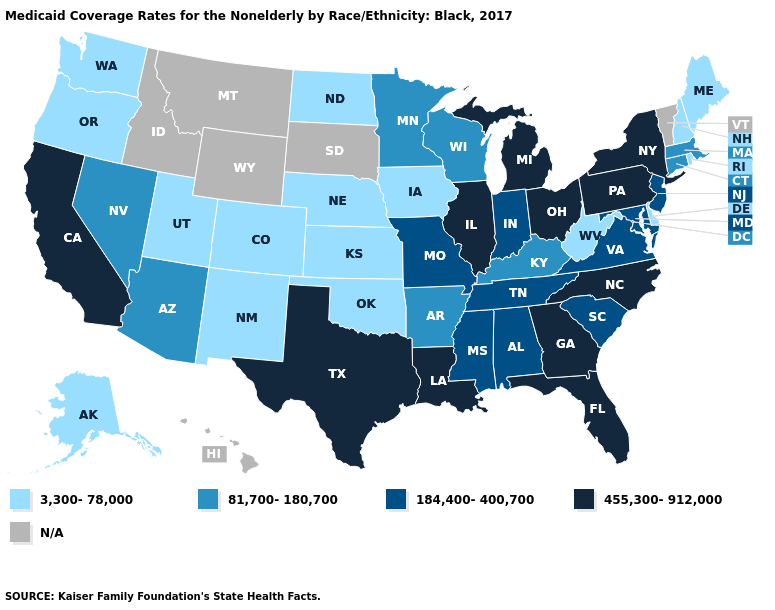What is the value of Virginia?
Be succinct. 184,400-400,700. Does New Jersey have the highest value in the Northeast?
Answer briefly. No. What is the highest value in the MidWest ?
Answer briefly. 455,300-912,000. Name the states that have a value in the range 3,300-78,000?
Write a very short answer. Alaska, Colorado, Delaware, Iowa, Kansas, Maine, Nebraska, New Hampshire, New Mexico, North Dakota, Oklahoma, Oregon, Rhode Island, Utah, Washington, West Virginia. What is the value of North Carolina?
Keep it brief. 455,300-912,000. What is the value of Louisiana?
Give a very brief answer. 455,300-912,000. What is the value of Vermont?
Give a very brief answer. N/A. What is the highest value in the South ?
Write a very short answer. 455,300-912,000. Does New York have the highest value in the Northeast?
Write a very short answer. Yes. Does the first symbol in the legend represent the smallest category?
Write a very short answer. Yes. Name the states that have a value in the range 184,400-400,700?
Write a very short answer. Alabama, Indiana, Maryland, Mississippi, Missouri, New Jersey, South Carolina, Tennessee, Virginia. What is the value of South Carolina?
Short answer required. 184,400-400,700. What is the lowest value in the South?
Be succinct. 3,300-78,000. 